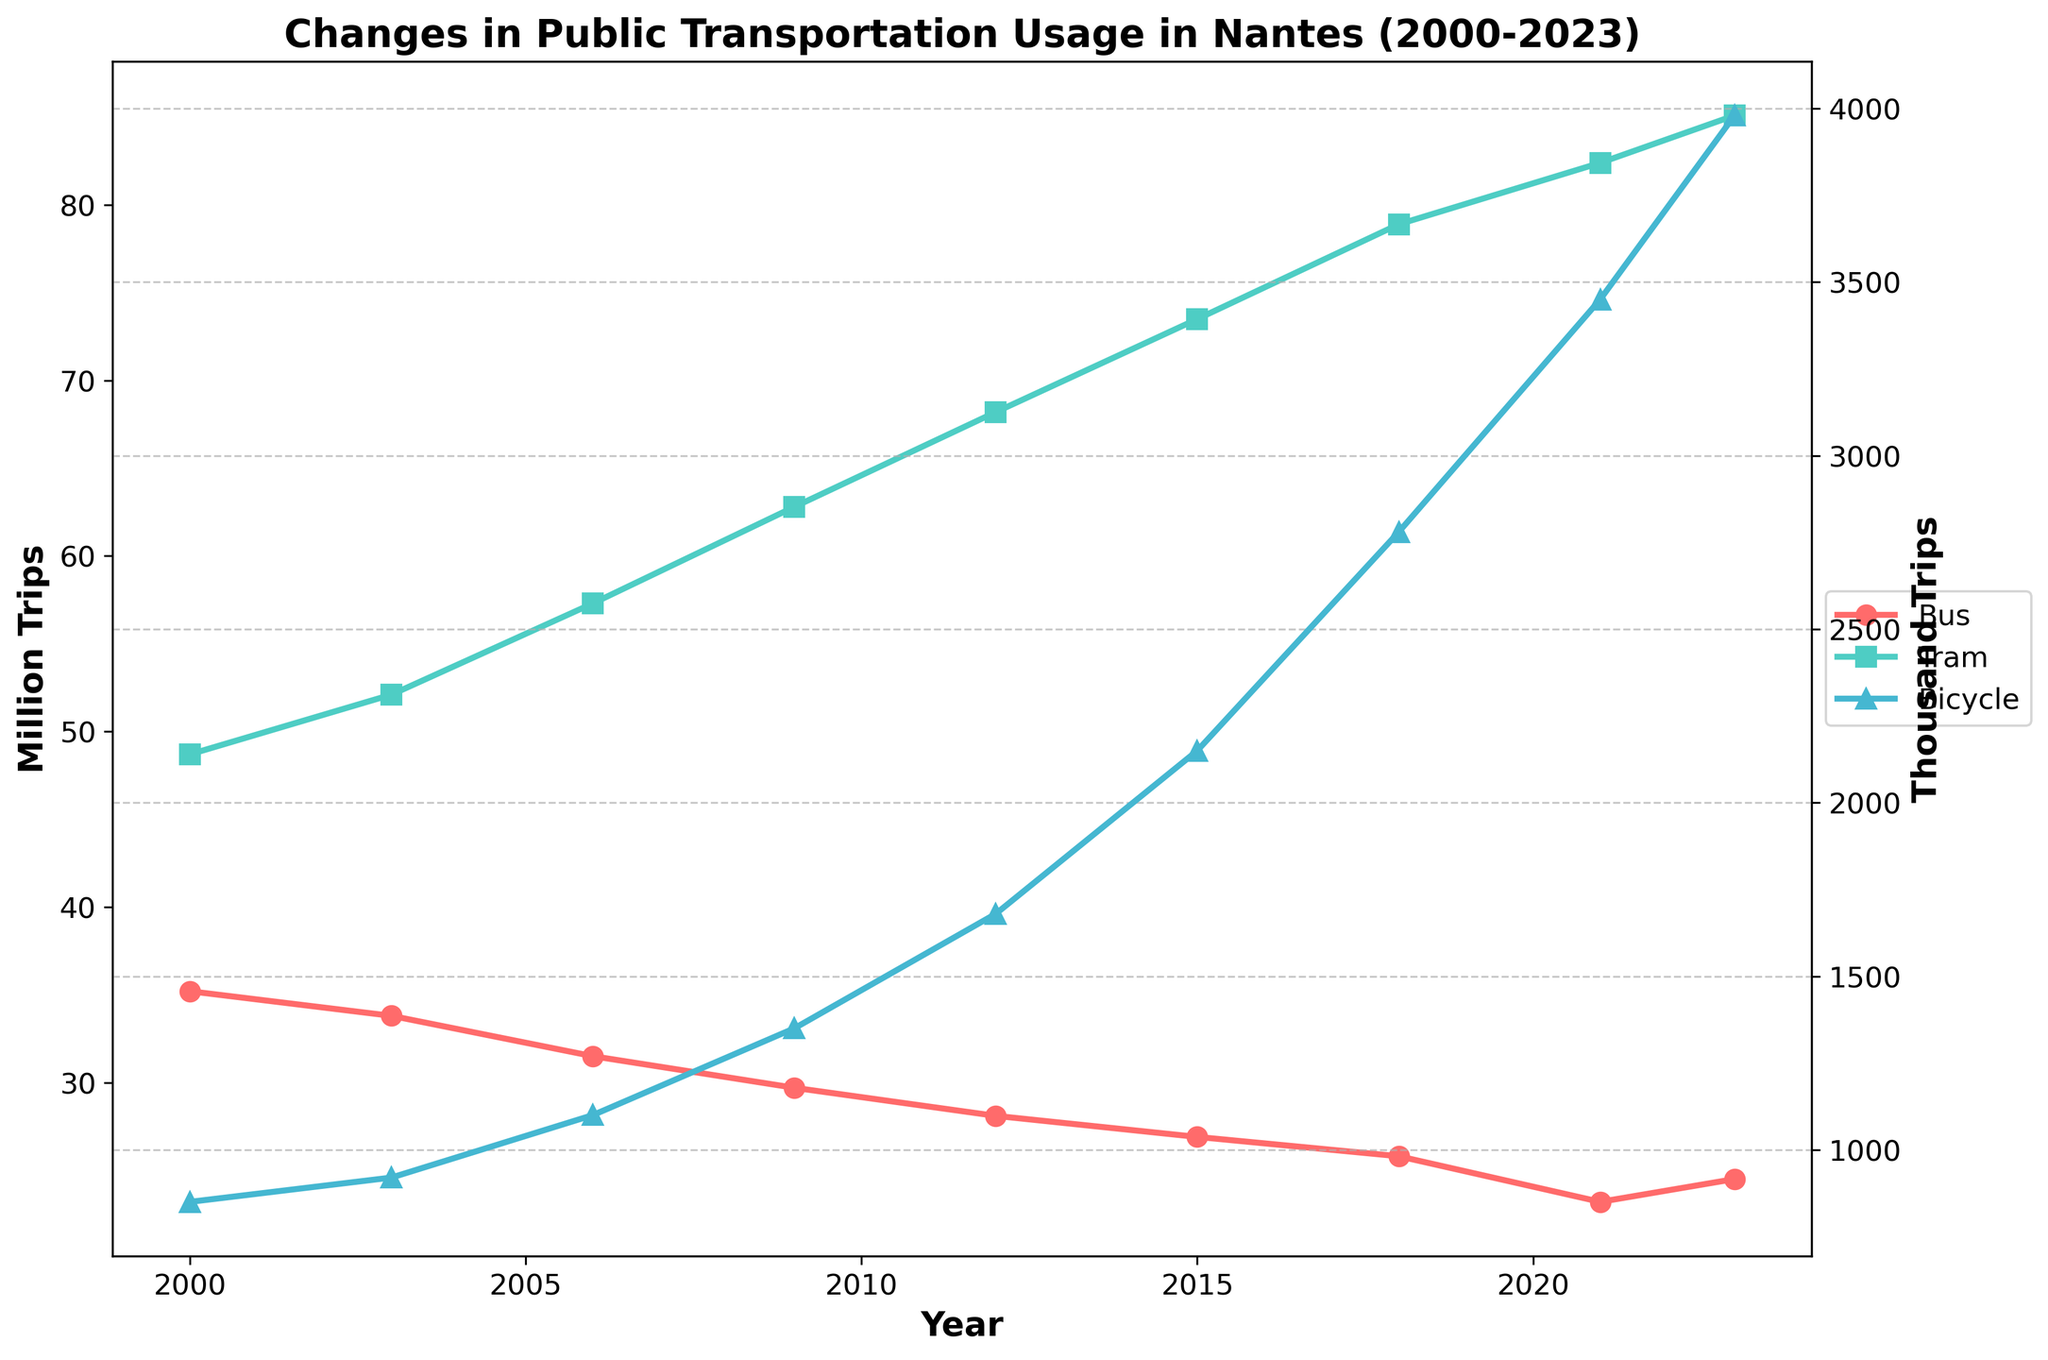Which mode of transportation had the highest usage in 2000? Looking at the starting point in 2000, the tram had the highest usage, with 48.7 million trips, compared to 35.2 million bus trips and 850 thousand bicycle trips.
Answer: Tram How did the tram usage change between 2003 and 2023? The tram usage in 2003 was 52.1 million trips and it increased to 85.1 million trips in 2023. The change is 85.1 - 52.1 = 33 million trips.
Answer: Increased by 33 million trips Which year had the lowest bicycle usage? By examining the chart, we can see that the year with the lowest bicycle usage is 2000, with 850 thousand trips.
Answer: 2000 Did bus usage in 2021 increase or decrease compared to 2015, and by how much? Bus usage in 2015 was 26.9 million trips and it decreased to 23.2 million trips in 2021. The difference is 26.9 - 23.2 = 3.7 million trips.
Answer: Decreased by 3.7 million trips In what year did bicycle usage most significantly increase compared to the previous data point? The significant increase occurred between 2018 and 2021. Bicycle usage went from 2780 thousand trips in 2018 to 3450 thousand trips in 2021, an increase of 670 thousand trips.
Answer: 2018 to 2021 Which mode of transportation saw the smallest overall increase from 2000 to 2023? The bus had the smallest overall increase. In fact, bus usage decreased from 35.2 million trips in 2000 to 24.5 million trips in 2023, a decrease of 10.7 million trips, while tram and bicycle saw increases.
Answer: Bus Comparing 2006 to 2015, which mode of transportation grew the most in absolute terms? Between 2006 and 2015, bicycle usage grew the most. Bicycle trips increased from 1100 thousand in 2006 to 2150 thousand in 2015, which is an increase of 1050 thousand trips.
Answer: Bicycle What was the overall trend in bicycle usage from 2000 to 2023? The overall trend in bicycle usage shows a steady increase from 850 thousand trips in 2000 to 3980 thousand trips in 2023.
Answer: Increasing By how much did tram usage surpass bus usage in 2023? In 2023, tram usage was 85.1 million trips and bus usage was 24.5 million trips. The difference is 85.1 - 24.5 = 60.6 million trips.
Answer: By 60.6 million trips 